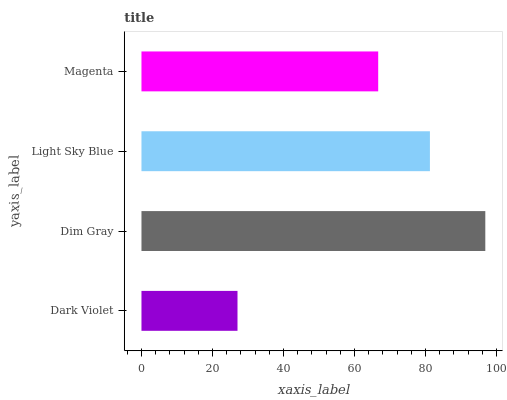Is Dark Violet the minimum?
Answer yes or no. Yes. Is Dim Gray the maximum?
Answer yes or no. Yes. Is Light Sky Blue the minimum?
Answer yes or no. No. Is Light Sky Blue the maximum?
Answer yes or no. No. Is Dim Gray greater than Light Sky Blue?
Answer yes or no. Yes. Is Light Sky Blue less than Dim Gray?
Answer yes or no. Yes. Is Light Sky Blue greater than Dim Gray?
Answer yes or no. No. Is Dim Gray less than Light Sky Blue?
Answer yes or no. No. Is Light Sky Blue the high median?
Answer yes or no. Yes. Is Magenta the low median?
Answer yes or no. Yes. Is Magenta the high median?
Answer yes or no. No. Is Light Sky Blue the low median?
Answer yes or no. No. 